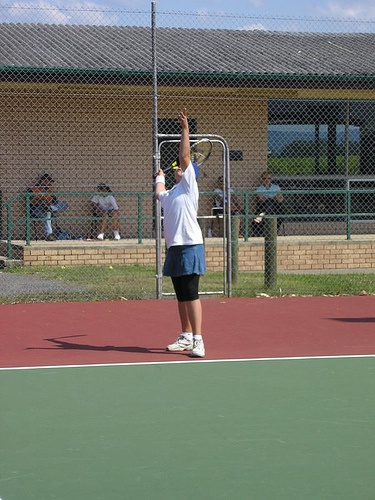Describe the objects in this image and their specific colors. I can see people in lavender, black, brown, and gray tones, people in lavender, black, and gray tones, people in lavender, gray, black, and maroon tones, people in lavender, gray, and black tones, and tennis racket in lavender, gray, black, and darkgray tones in this image. 